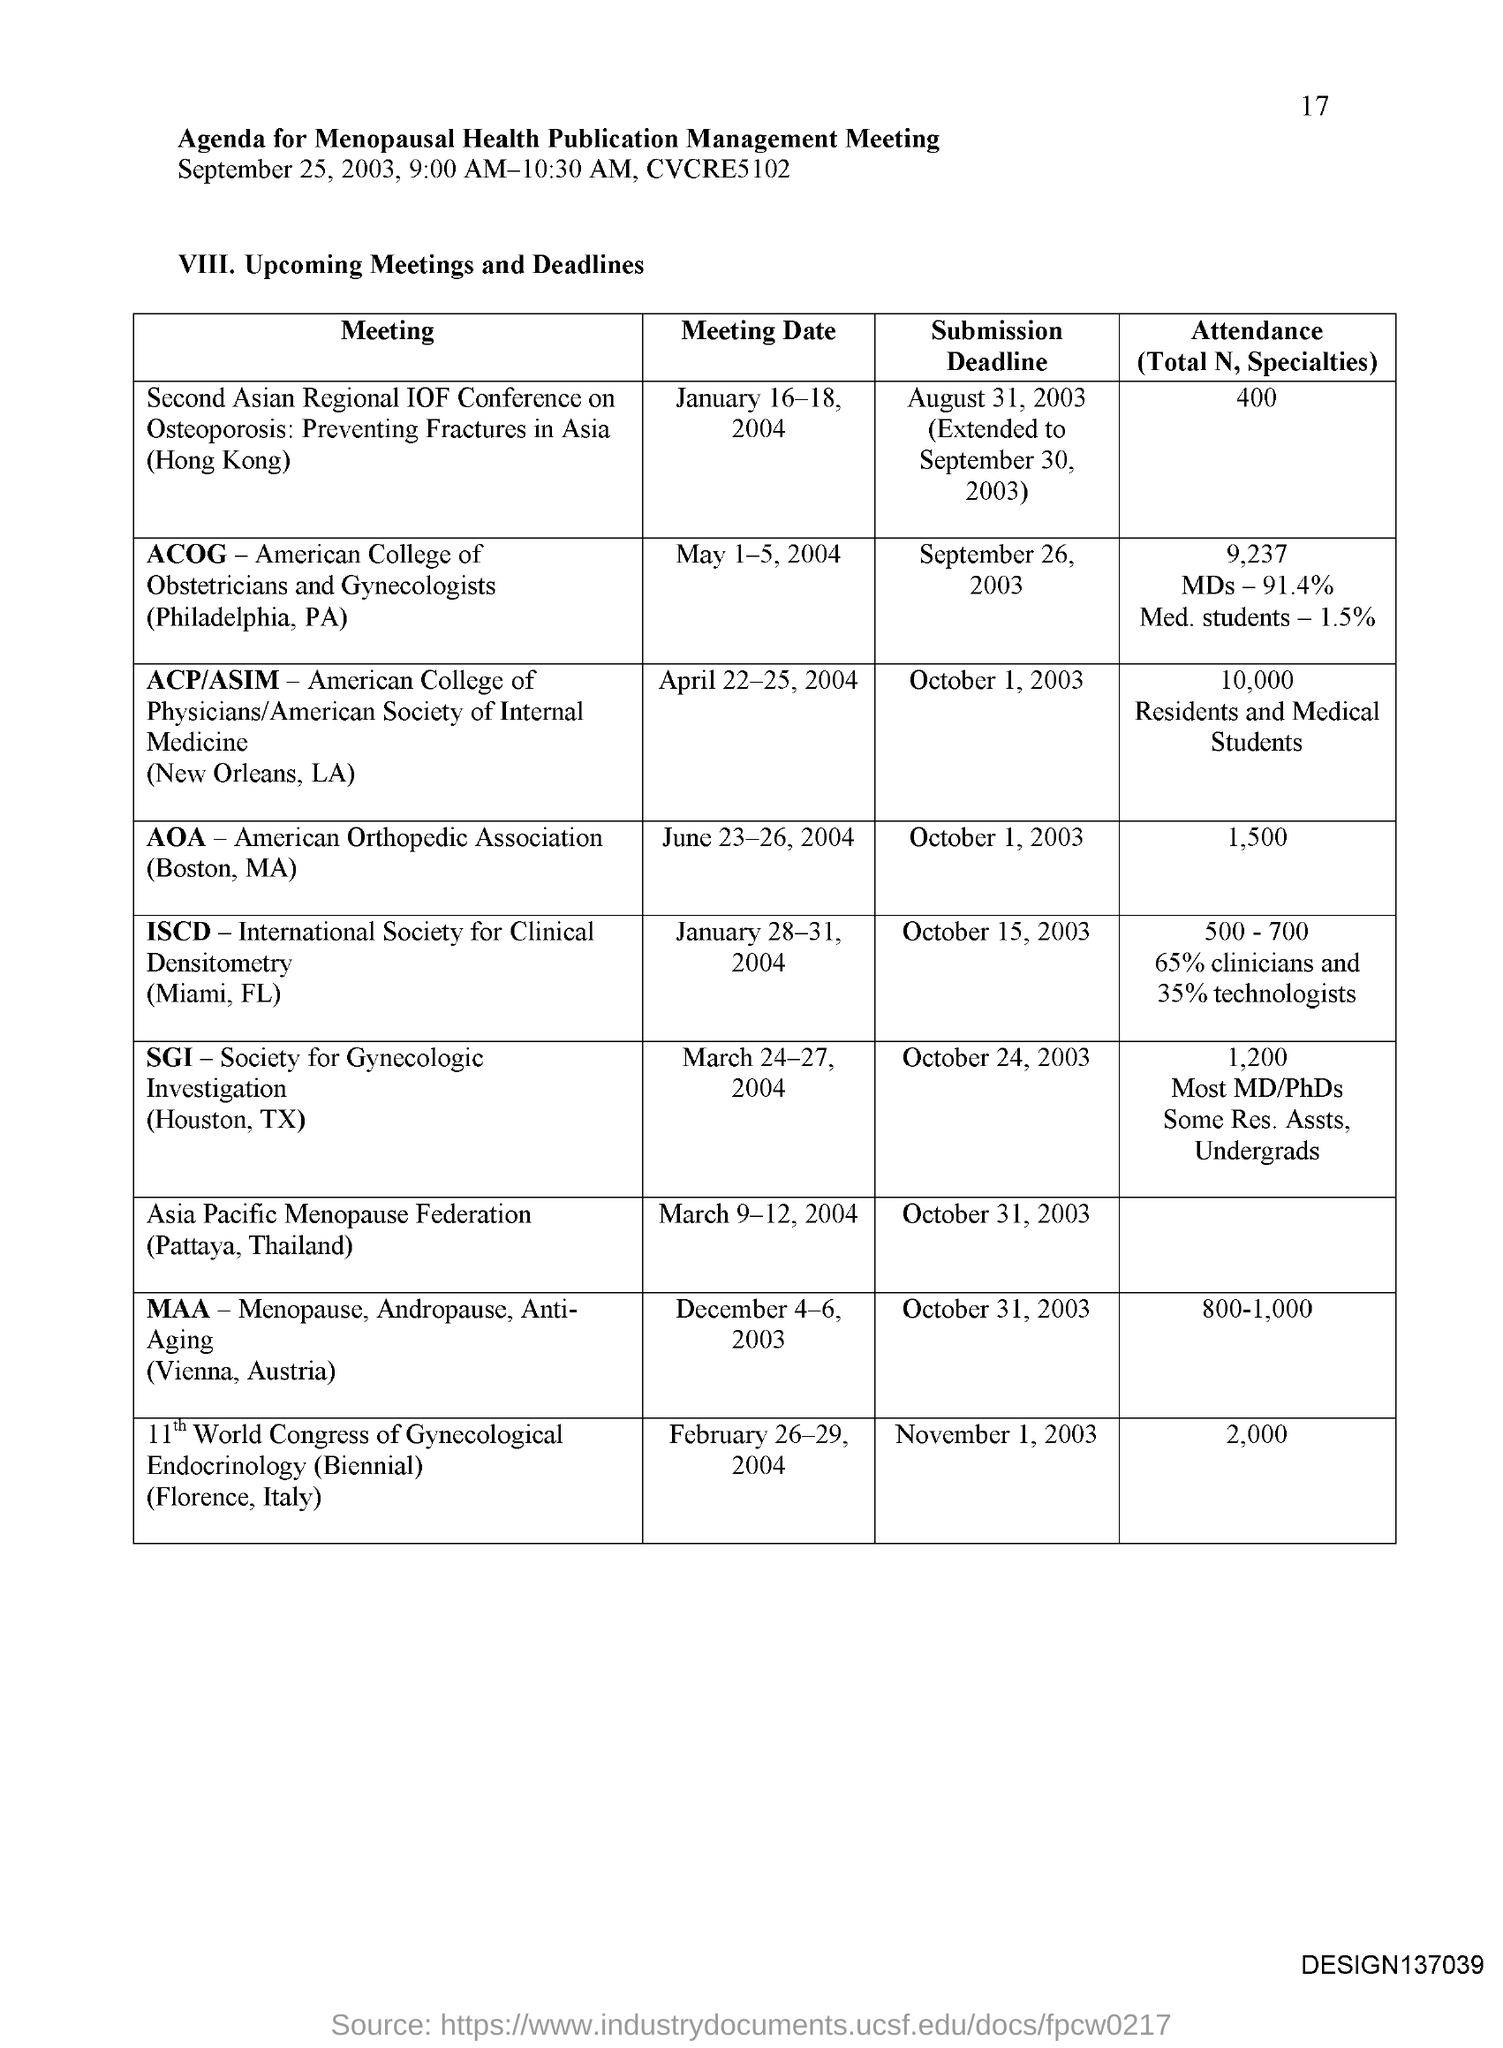Specify some key components in this picture. The meeting date for SGI is from March 24-27, 2004. The abbreviation for ACP, which stands for American College of Physicians, is ACP. The abbreviation for ACOG is the American College of Obstetricians and Gynecologists. The submission deadline for the MAA is October 31, 2003. The abbreviation for SGI is Society for Gynecologic Investigation. 